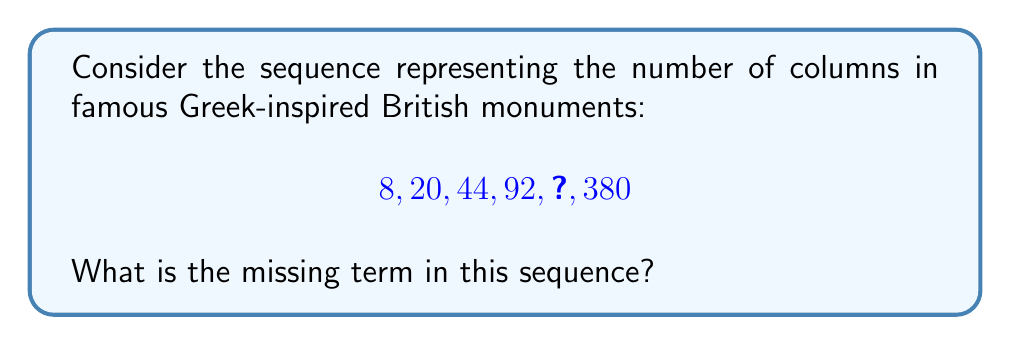Can you solve this math problem? To solve this problem, let's analyze the pattern in the given sequence:

1) First, calculate the differences between consecutive terms:
   $20 - 8 = 12$
   $44 - 20 = 24$
   $92 - 44 = 48$
   $380 - ? = ?$

2) We can see that these differences are doubling each time:
   $12 \times 2 = 24$
   $24 \times 2 = 48$
   $48 \times 2 = 96$

3) This suggests that the pattern is:
   $$a_n = a_{n-1} + 12 \times 2^{n-2}$$
   Where $a_n$ is the nth term of the sequence, and $n$ starts at 1.

4) To find the missing term, we need to calculate the 5th term:
   $$a_5 = a_4 + 12 \times 2^{5-2}$$
   $$a_5 = 92 + 12 \times 2^3$$
   $$a_5 = 92 + 12 \times 8$$
   $$a_5 = 92 + 96$$
   $$a_5 = 188$$

5) We can verify this by checking if it fits the pattern for the 6th term:
   $$380 = 188 + 12 \times 2^4$$
   $$380 = 188 + 192$$
   Which is correct.

Therefore, the missing term in the sequence is 188.
Answer: 188 